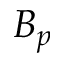Convert formula to latex. <formula><loc_0><loc_0><loc_500><loc_500>B _ { p }</formula> 